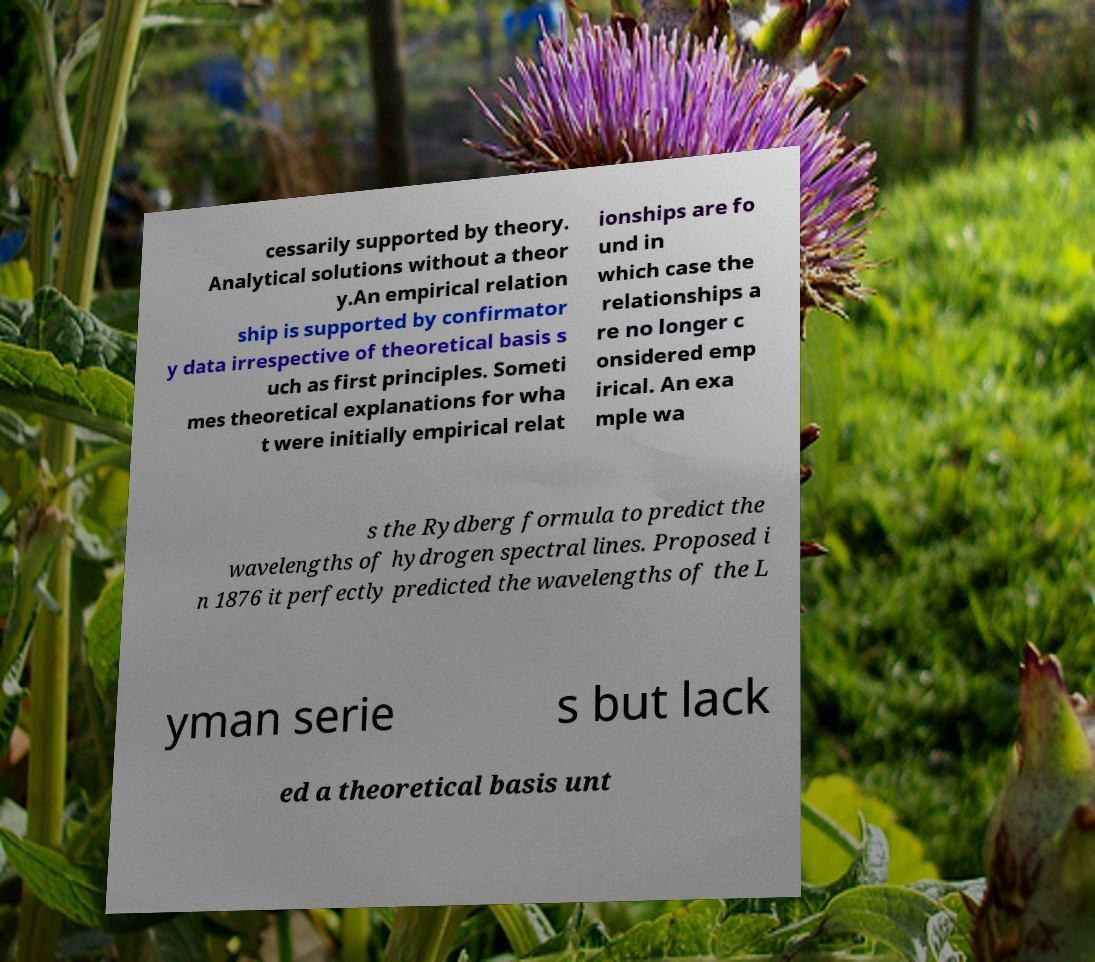I need the written content from this picture converted into text. Can you do that? cessarily supported by theory. Analytical solutions without a theor y.An empirical relation ship is supported by confirmator y data irrespective of theoretical basis s uch as first principles. Someti mes theoretical explanations for wha t were initially empirical relat ionships are fo und in which case the relationships a re no longer c onsidered emp irical. An exa mple wa s the Rydberg formula to predict the wavelengths of hydrogen spectral lines. Proposed i n 1876 it perfectly predicted the wavelengths of the L yman serie s but lack ed a theoretical basis unt 